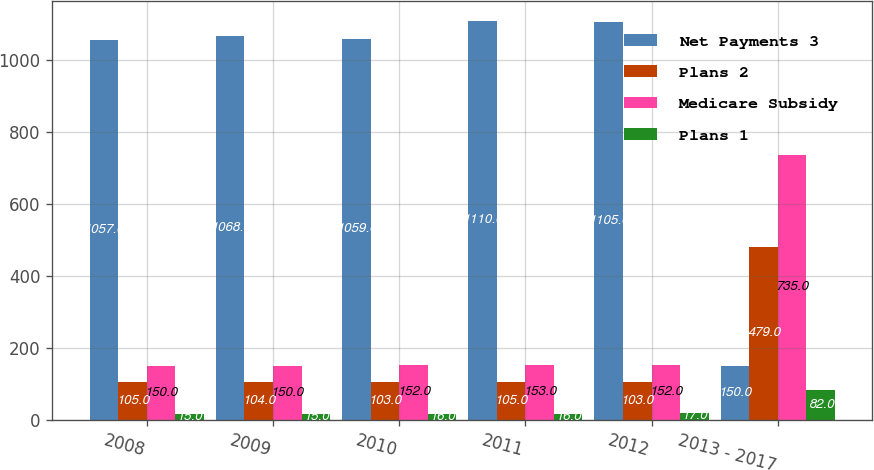Convert chart to OTSL. <chart><loc_0><loc_0><loc_500><loc_500><stacked_bar_chart><ecel><fcel>2008<fcel>2009<fcel>2010<fcel>2011<fcel>2012<fcel>2013 - 2017<nl><fcel>Net Payments 3<fcel>1057<fcel>1068<fcel>1059<fcel>1110<fcel>1105<fcel>150<nl><fcel>Plans 2<fcel>105<fcel>104<fcel>103<fcel>105<fcel>103<fcel>479<nl><fcel>Medicare Subsidy<fcel>150<fcel>150<fcel>152<fcel>153<fcel>152<fcel>735<nl><fcel>Plans 1<fcel>15<fcel>15<fcel>16<fcel>16<fcel>17<fcel>82<nl></chart> 